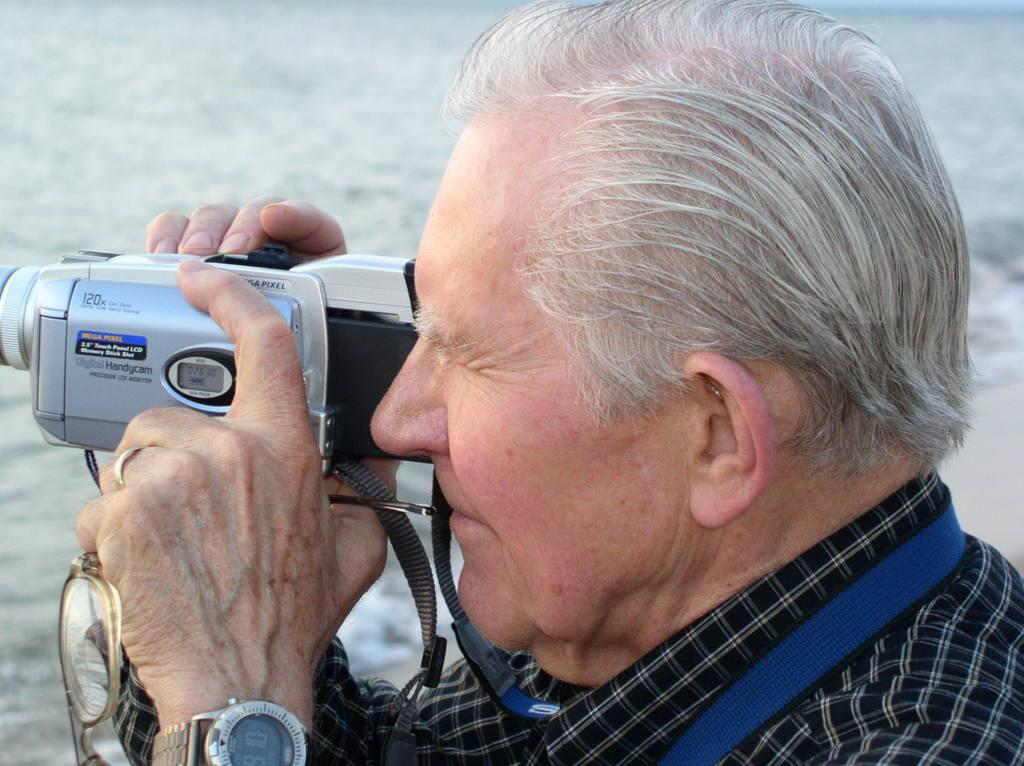What is the main subject of the picture? The main subject of the picture is a man. What is the man holding in his hand? The man is holding a camera and a spectacle in his hand. Can you describe the camera's appearance? The camera is grey in color. What type of salt can be seen on the man's hair in the image? There is no salt or hair visible on the man in the image; he is only holding a camera and a spectacle. 